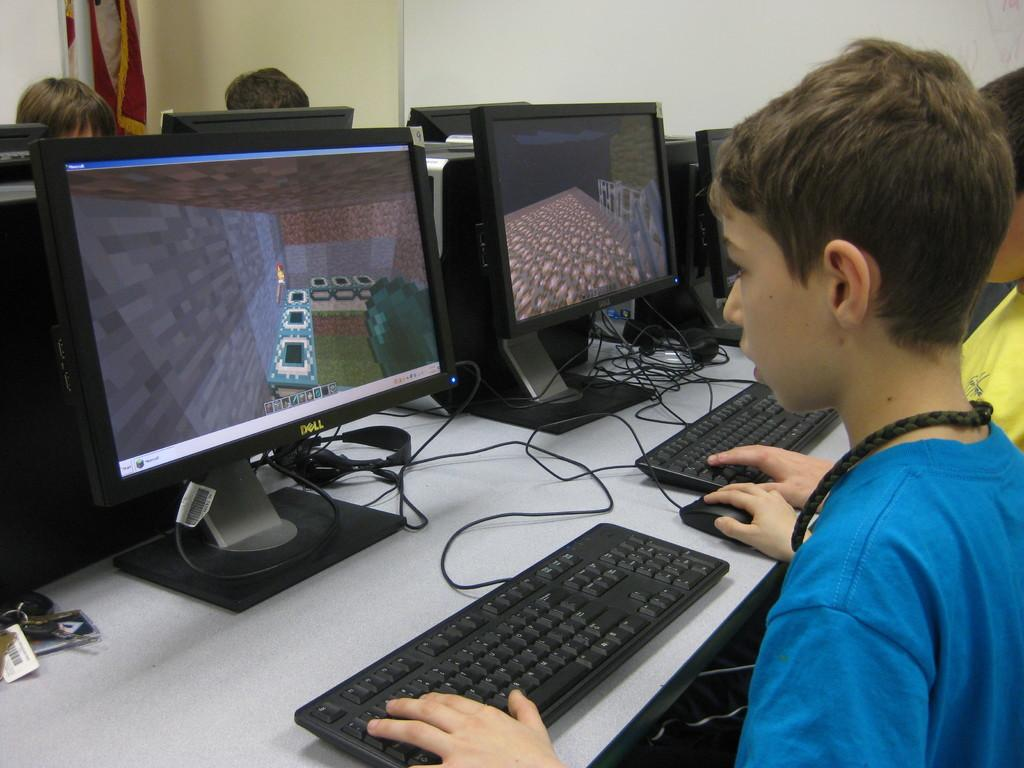<image>
Provide a brief description of the given image. A kid at a PC with a Dell branded monitor. 